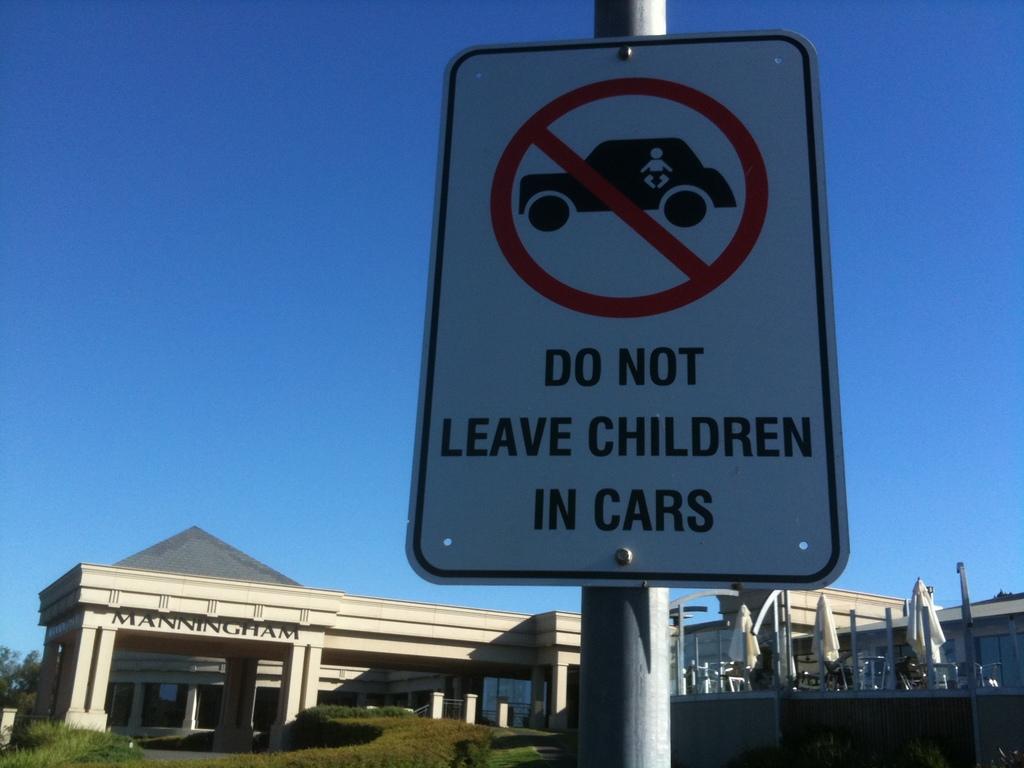What is the building name?
Provide a succinct answer. Manningham. 